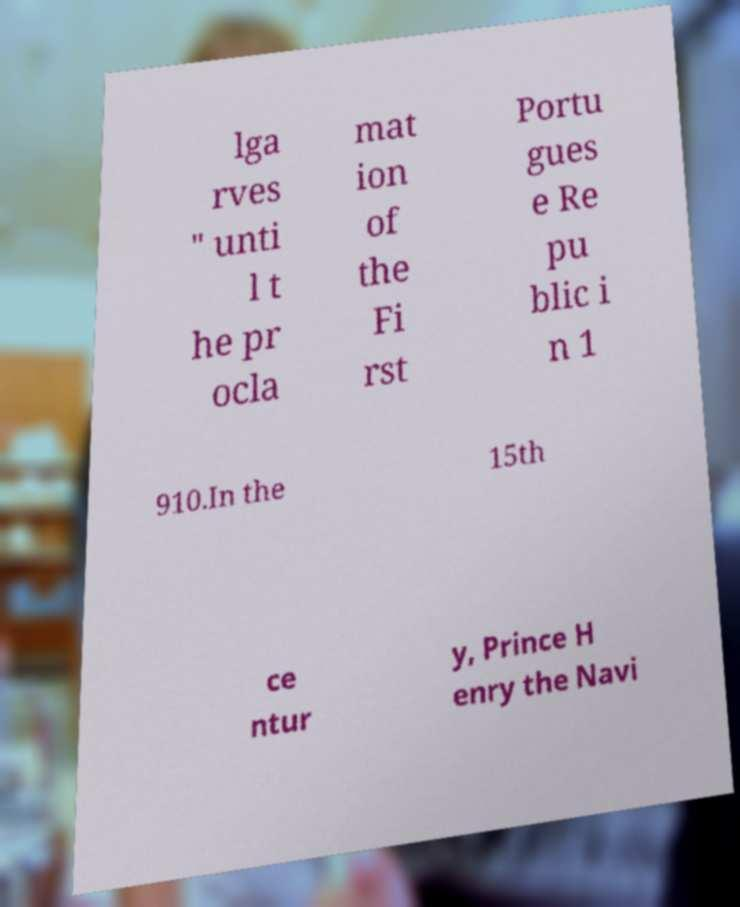What messages or text are displayed in this image? I need them in a readable, typed format. lga rves " unti l t he pr ocla mat ion of the Fi rst Portu gues e Re pu blic i n 1 910.In the 15th ce ntur y, Prince H enry the Navi 